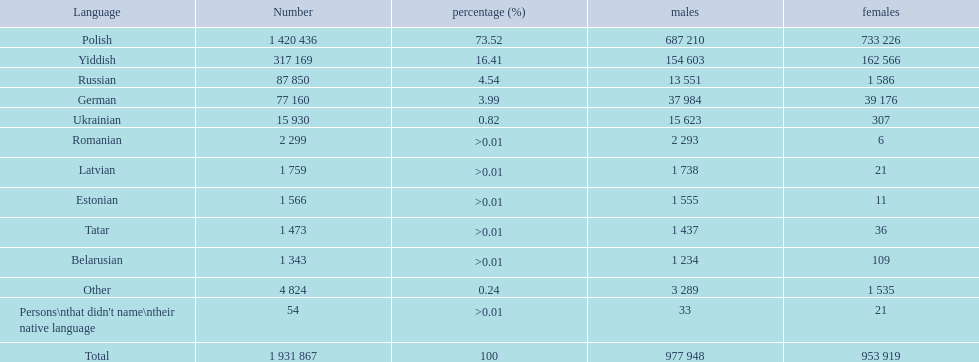What are all the tongues? Polish, Yiddish, Russian, German, Ukrainian, Romanian, Latvian, Estonian, Tatar, Belarusian, Other, Persons\nthat didn't name\ntheir native language. Among those tongues, which five had less than 50 females conversing in it? 6, 21, 11, 36, 21. Of those five tongues, which one is the least? Romanian. 